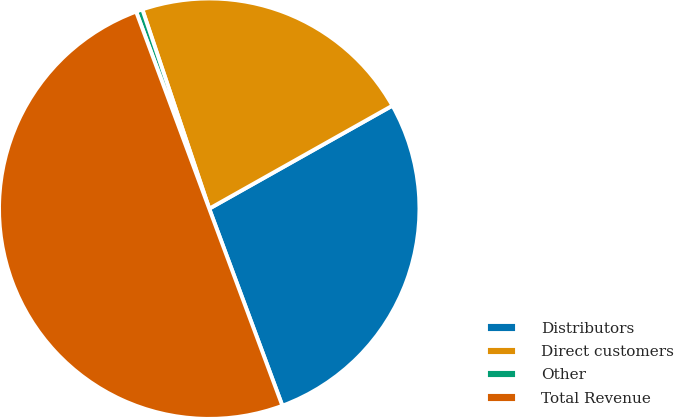Convert chart. <chart><loc_0><loc_0><loc_500><loc_500><pie_chart><fcel>Distributors<fcel>Direct customers<fcel>Other<fcel>Total Revenue<nl><fcel>27.5%<fcel>22.0%<fcel>0.5%<fcel>50.0%<nl></chart> 